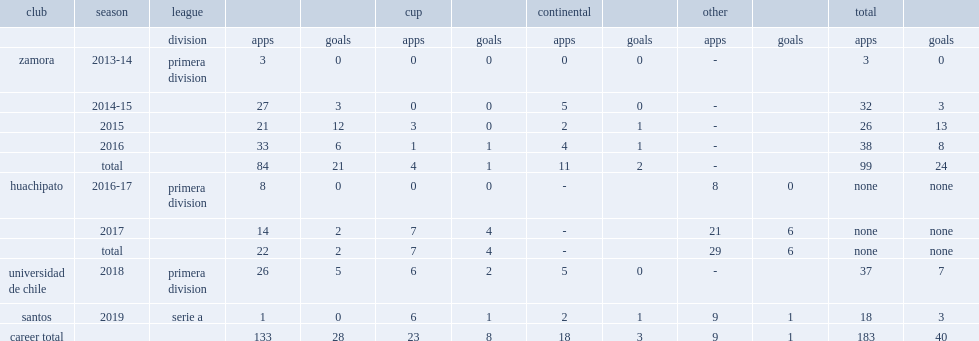In 2019, which club did soteldo belong to? Santos. 